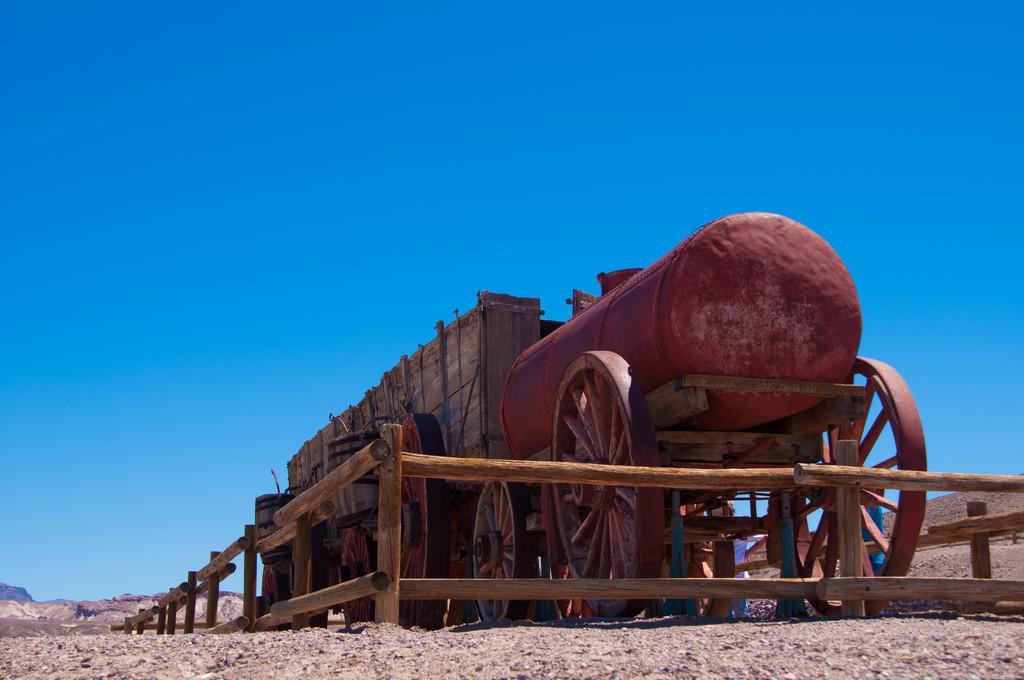How would you summarize this image in a sentence or two? This image consists of a cart. On which we can see an iron barrel. And there is a fencing made up of wood. At the bottom, there is ground. At the top, there is sky. 